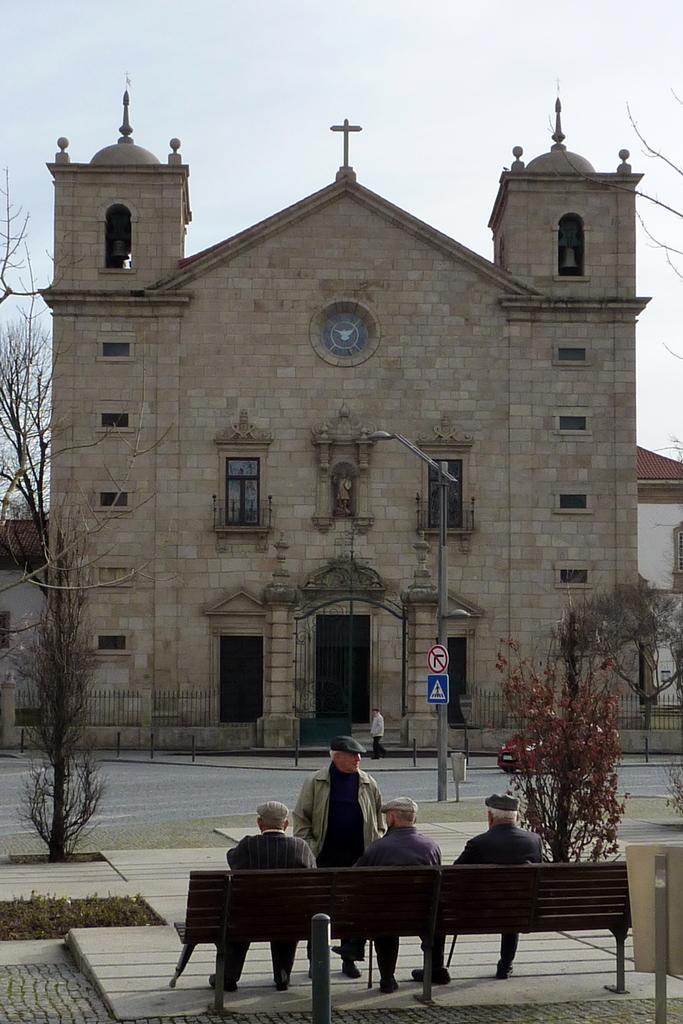In one or two sentences, can you explain what this image depicts? There are three persons sitting in a bench and there is another standing in front of them and there is a church in front of them. 